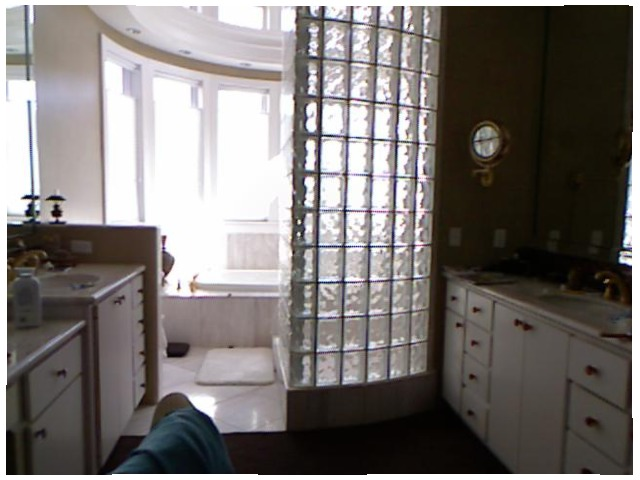<image>
Is there a sink in front of the cabinet? No. The sink is not in front of the cabinet. The spatial positioning shows a different relationship between these objects. Is the woman showers to the left of the tissue paper? No. The woman showers is not to the left of the tissue paper. From this viewpoint, they have a different horizontal relationship. 